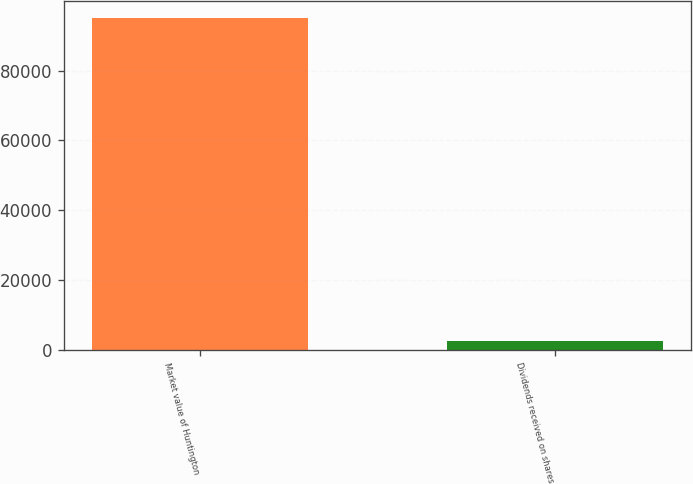<chart> <loc_0><loc_0><loc_500><loc_500><bar_chart><fcel>Market value of Huntington<fcel>Dividends received on shares<nl><fcel>95160<fcel>2414<nl></chart> 